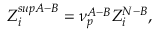<formula> <loc_0><loc_0><loc_500><loc_500>Z _ { i } ^ { s u p A - B } = \nu _ { p } ^ { A - B } Z _ { i } ^ { N - B } ,</formula> 